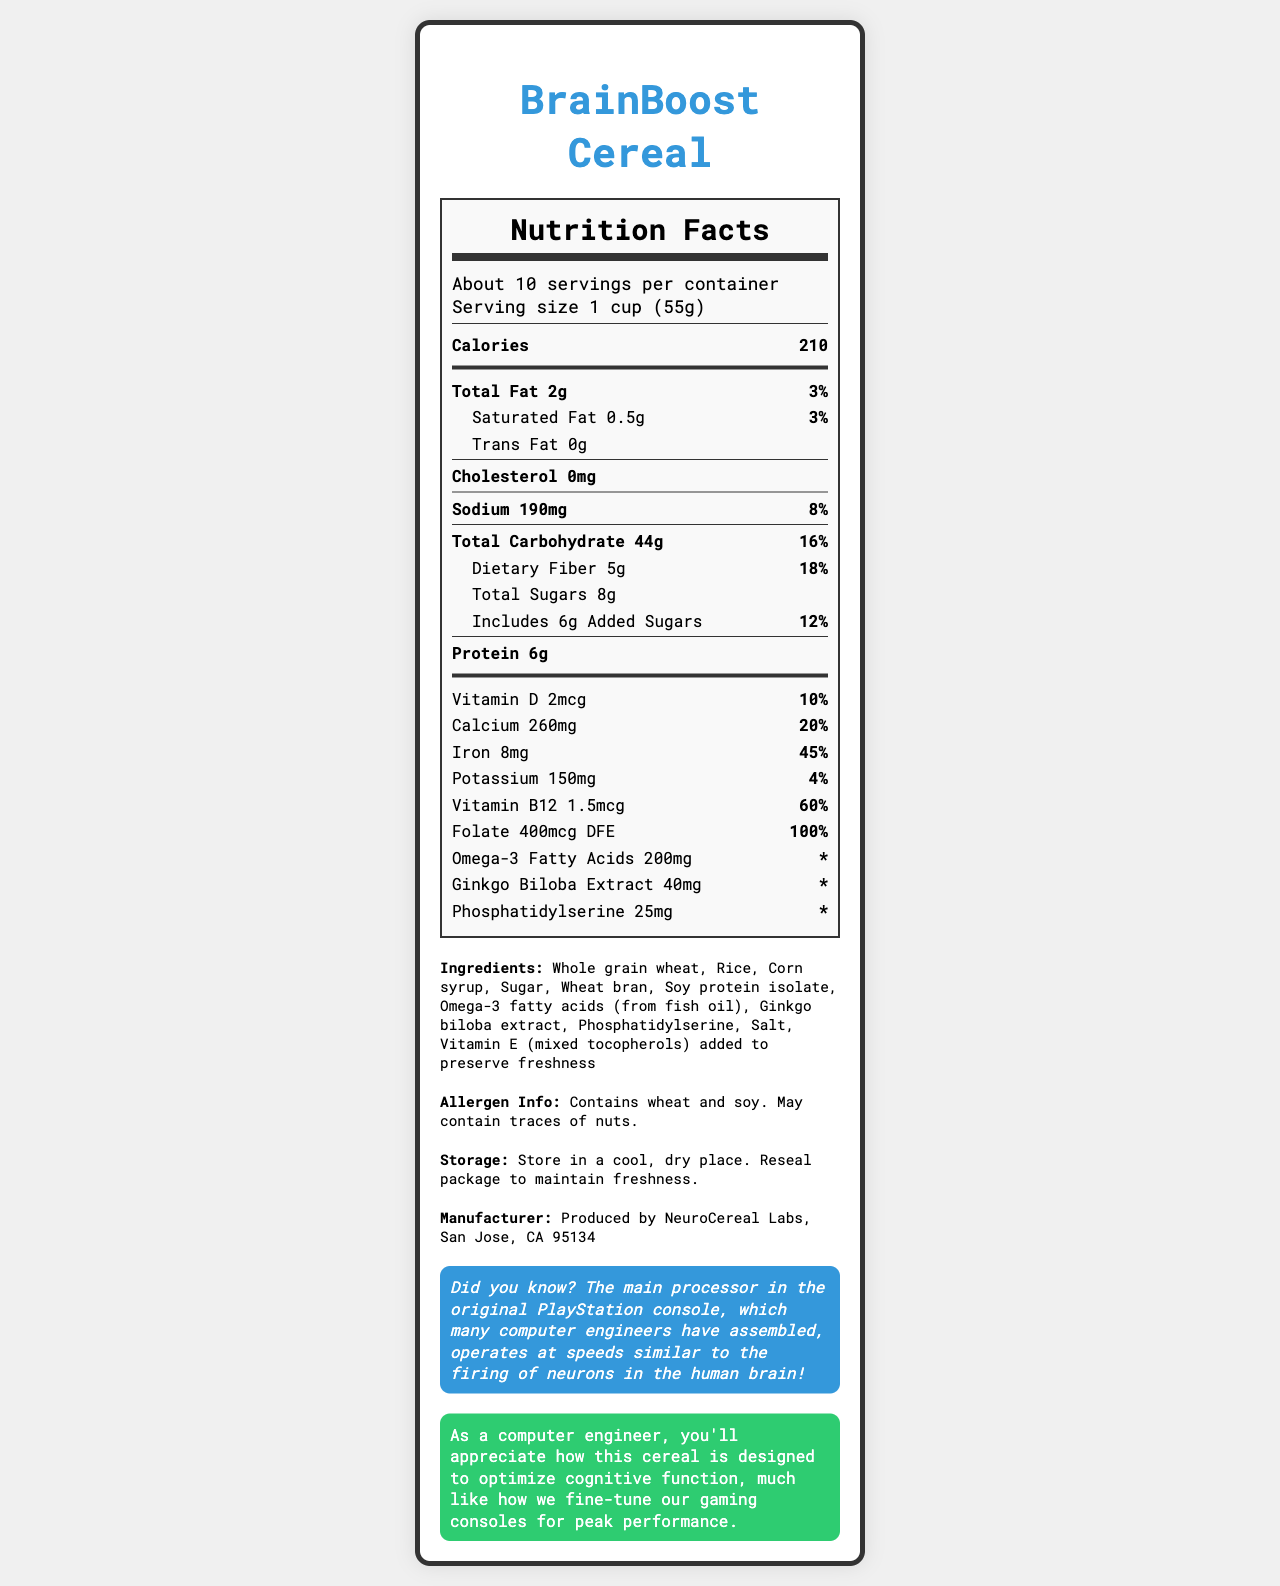what is the serving size of BrainBoost Cereal? The serving size is directly mentioned as "1 cup (55g)" in the document.
Answer: 1 cup (55g) How many calories are in one serving of BrainBoost Cereal? The document specifies that each serving contains 210 calories.
Answer: 210 calories What percentage of the daily value for iron is provided by BrainBoost Cereal? The daily value for iron is explicitly stated to be 45% per serving.
Answer: 45% Which vitamin in BrainBoost Cereal has the highest daily value percentage? According to the document, Folate has the highest daily value percentage at 100%.
Answer: Folate (100%) How much protein does one serving of BrainBoost Cereal contain? The amount of protein per serving is listed as 6 grams.
Answer: 6g Which ingredients in BrainBoost Cereal contribute to cognitive function? A. Whole grain wheat B. Ginkgo biloba extract C. Soy protein isolate D. Sugar The ingredients list includes "Ginkgo biloba extract," which is known for its cognitive enhancement benefits.
Answer: B What is the sodium content in BrainBoost Cereal per serving? A. 190mg B. 260mg C. 150mg The sodium content per serving is given as 190mg.
Answer: A How many servings are in one container of BrainBoost Cereal? A. About 5 B. About 10 C. About 15 The document states there are "About 10" servings per container.
Answer: B Does BrainBoost Cereal contain any trans fat? The document indicates that there is "0g" trans fat.
Answer: No Summarize the main idea of the BrainBoost Cereal Nutrition Facts label. The main idea of the document is to provide comprehensive nutritional information about BrainBoost Cereal, highlighting its cognitive benefits through specific ingredients and their respective quantities.
Answer: BrainBoost Cereal is a vitamin-fortified cereal designed to enhance cognitive function. The label details nutritional information, such as serving size, calories, and daily values of various nutrients. The cereal contains ingredients like omega-3 fatty acids, ginkgo biloba extract, and phosphatidylserine, targeted at improving brain health. It also includes general information, storage instructions, and a fun fact about the product's cognitive benefits. What is the daily value percentage for Vitamin B12 in BrainBoost Cereal? The daily value percentage for Vitamin B12 is listed as 60%.
Answer: 60% List two allergens that are present in BrainBoost Cereal. The allergen information section specifies that the cereal contains wheat and soy.
Answer: Wheat and soy What is the amount of added sugars in a serving of BrainBoost Cereal? The amount of added sugars per serving is stated as 6 grams.
Answer: 6g Where is BrainBoost Cereal produced? The manufacturer information lists the production location as San Jose, CA 95134.
Answer: San Jose, CA 95134 What is the amount of dietary fiber in one serving of BrainBoost Cereal? The dietary fiber content per serving is listed as 5 grams.
Answer: 5g Does BrainBoost Cereal contain any cholesterol? The document clearly states that there is "0mg" of cholesterol per serving.
Answer: No How many milligrams of omega-3 fatty acids are in one serving of BrainBoost Cereal? The omega-3 fatty acids content per serving is given as 200mg.
Answer: 200mg What is the fun fact mentioned on the BrainBoost Cereal Nutrition Facts label? The fun fact on the document states this interesting comparison between the PlayStation processor and human neuron firing speeds.
Answer: The main processor in the original PlayStation console operates at speeds similar to the firing of neurons in the human brain! What is the source of omega-3 fatty acids in BrainBoost Cereal? The ingredients list specifies that the omega-3 fatty acids are sourced from fish oil.
Answer: Omega-3 fatty acids (from fish oil) Is the BrainBoost Cereal suitable for people with nut allergies? The allergen information mentions that it may contain traces of nuts, which means it's uncertain whether it's completely safe for those with nut allergies.
Answer: Cannot be determined 